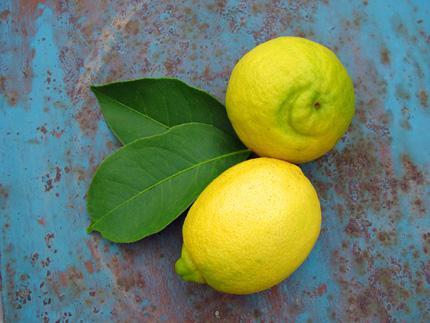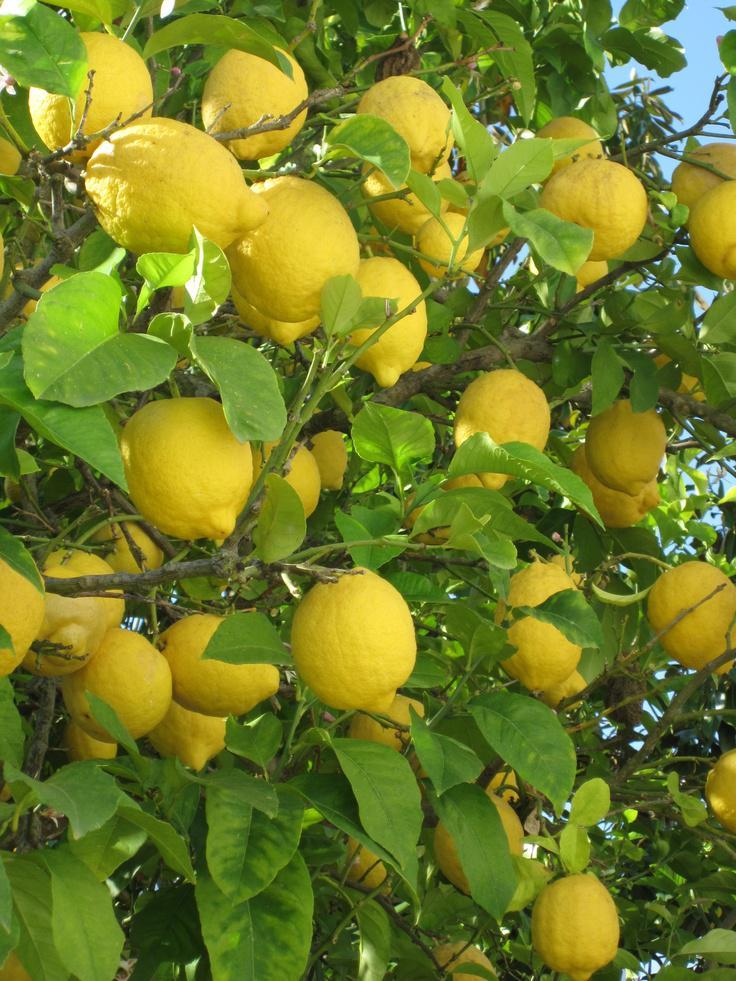The first image is the image on the left, the second image is the image on the right. Assess this claim about the two images: "The lemons are still hanging from the tree in one picture.". Correct or not? Answer yes or no. Yes. The first image is the image on the left, the second image is the image on the right. Considering the images on both sides, is "A single half of a lemon sits with some whole lemons in each of the images." valid? Answer yes or no. No. 